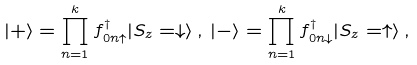<formula> <loc_0><loc_0><loc_500><loc_500>| + \rangle = \prod _ { n = 1 } ^ { k } f ^ { \dagger } _ { 0 n \uparrow } | S _ { z } = \downarrow \rangle \, , \, | - \rangle = \prod _ { n = 1 } ^ { k } f ^ { \dagger } _ { 0 n \downarrow } | S _ { z } = \uparrow \rangle \, ,</formula> 